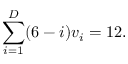Convert formula to latex. <formula><loc_0><loc_0><loc_500><loc_500>\sum _ { i = 1 } ^ { D } ( 6 - i ) v _ { i } = 1 2 .</formula> 